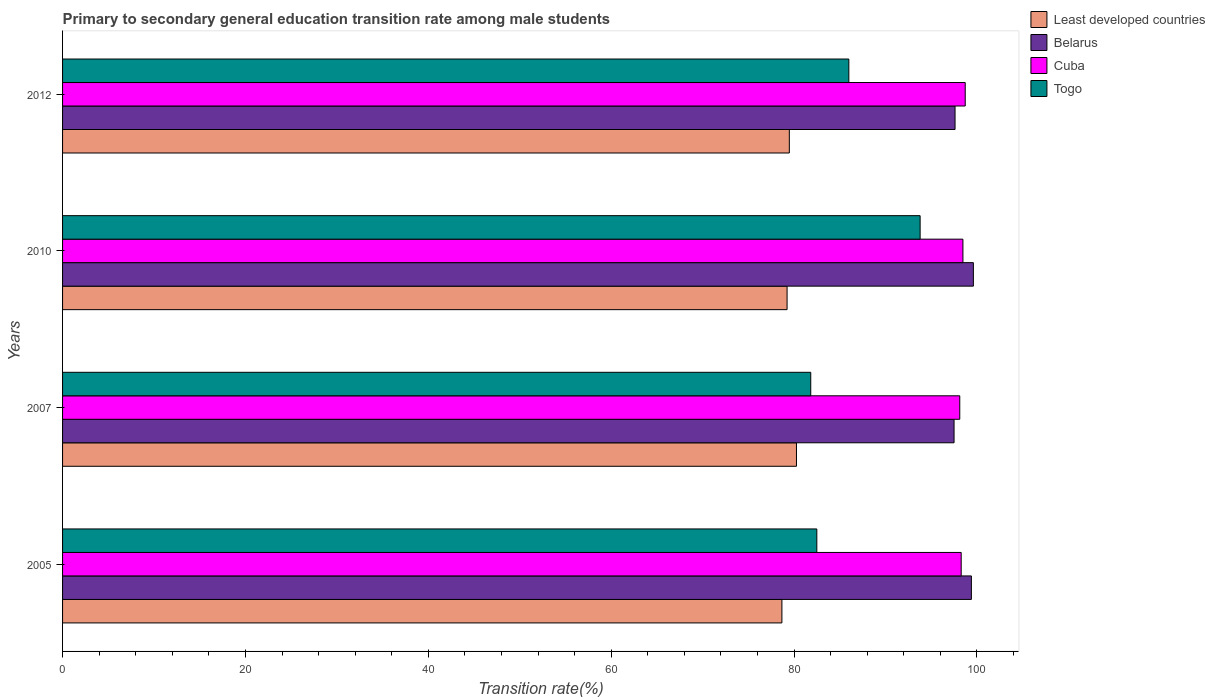Are the number of bars on each tick of the Y-axis equal?
Offer a terse response. Yes. What is the transition rate in Cuba in 2007?
Keep it short and to the point. 98.12. Across all years, what is the maximum transition rate in Cuba?
Keep it short and to the point. 98.72. Across all years, what is the minimum transition rate in Least developed countries?
Give a very brief answer. 78.67. In which year was the transition rate in Cuba minimum?
Your answer should be very brief. 2007. What is the total transition rate in Least developed countries in the graph?
Keep it short and to the point. 317.64. What is the difference between the transition rate in Belarus in 2005 and that in 2010?
Your answer should be compact. -0.22. What is the difference between the transition rate in Belarus in 2010 and the transition rate in Least developed countries in 2005?
Your response must be concise. 20.94. What is the average transition rate in Togo per year?
Keep it short and to the point. 86.02. In the year 2007, what is the difference between the transition rate in Cuba and transition rate in Least developed countries?
Offer a terse response. 17.86. In how many years, is the transition rate in Belarus greater than 12 %?
Offer a very short reply. 4. What is the ratio of the transition rate in Belarus in 2010 to that in 2012?
Keep it short and to the point. 1.02. Is the transition rate in Least developed countries in 2010 less than that in 2012?
Offer a terse response. Yes. Is the difference between the transition rate in Cuba in 2007 and 2012 greater than the difference between the transition rate in Least developed countries in 2007 and 2012?
Your answer should be very brief. No. What is the difference between the highest and the second highest transition rate in Togo?
Ensure brevity in your answer.  7.8. What is the difference between the highest and the lowest transition rate in Least developed countries?
Your response must be concise. 1.59. Is the sum of the transition rate in Togo in 2007 and 2010 greater than the maximum transition rate in Least developed countries across all years?
Make the answer very short. Yes. What does the 1st bar from the top in 2007 represents?
Provide a succinct answer. Togo. What does the 4th bar from the bottom in 2010 represents?
Offer a terse response. Togo. Is it the case that in every year, the sum of the transition rate in Cuba and transition rate in Belarus is greater than the transition rate in Togo?
Keep it short and to the point. Yes. How many years are there in the graph?
Keep it short and to the point. 4. Does the graph contain any zero values?
Offer a very short reply. No. Does the graph contain grids?
Provide a succinct answer. No. How are the legend labels stacked?
Provide a short and direct response. Vertical. What is the title of the graph?
Make the answer very short. Primary to secondary general education transition rate among male students. Does "Trinidad and Tobago" appear as one of the legend labels in the graph?
Ensure brevity in your answer.  No. What is the label or title of the X-axis?
Provide a short and direct response. Transition rate(%). What is the Transition rate(%) of Least developed countries in 2005?
Your answer should be very brief. 78.67. What is the Transition rate(%) of Belarus in 2005?
Ensure brevity in your answer.  99.39. What is the Transition rate(%) in Cuba in 2005?
Make the answer very short. 98.28. What is the Transition rate(%) of Togo in 2005?
Give a very brief answer. 82.49. What is the Transition rate(%) of Least developed countries in 2007?
Provide a short and direct response. 80.26. What is the Transition rate(%) in Belarus in 2007?
Offer a very short reply. 97.49. What is the Transition rate(%) of Cuba in 2007?
Make the answer very short. 98.12. What is the Transition rate(%) in Togo in 2007?
Make the answer very short. 81.82. What is the Transition rate(%) in Least developed countries in 2010?
Provide a succinct answer. 79.23. What is the Transition rate(%) of Belarus in 2010?
Offer a very short reply. 99.61. What is the Transition rate(%) of Cuba in 2010?
Ensure brevity in your answer.  98.46. What is the Transition rate(%) in Togo in 2010?
Keep it short and to the point. 93.78. What is the Transition rate(%) in Least developed countries in 2012?
Ensure brevity in your answer.  79.48. What is the Transition rate(%) in Belarus in 2012?
Your answer should be very brief. 97.6. What is the Transition rate(%) in Cuba in 2012?
Ensure brevity in your answer.  98.72. What is the Transition rate(%) of Togo in 2012?
Provide a short and direct response. 85.99. Across all years, what is the maximum Transition rate(%) in Least developed countries?
Give a very brief answer. 80.26. Across all years, what is the maximum Transition rate(%) in Belarus?
Keep it short and to the point. 99.61. Across all years, what is the maximum Transition rate(%) of Cuba?
Ensure brevity in your answer.  98.72. Across all years, what is the maximum Transition rate(%) in Togo?
Your answer should be very brief. 93.78. Across all years, what is the minimum Transition rate(%) of Least developed countries?
Keep it short and to the point. 78.67. Across all years, what is the minimum Transition rate(%) in Belarus?
Provide a succinct answer. 97.49. Across all years, what is the minimum Transition rate(%) of Cuba?
Keep it short and to the point. 98.12. Across all years, what is the minimum Transition rate(%) of Togo?
Ensure brevity in your answer.  81.82. What is the total Transition rate(%) in Least developed countries in the graph?
Provide a short and direct response. 317.64. What is the total Transition rate(%) in Belarus in the graph?
Your response must be concise. 394.1. What is the total Transition rate(%) of Cuba in the graph?
Keep it short and to the point. 393.58. What is the total Transition rate(%) in Togo in the graph?
Offer a terse response. 344.08. What is the difference between the Transition rate(%) in Least developed countries in 2005 and that in 2007?
Give a very brief answer. -1.59. What is the difference between the Transition rate(%) of Belarus in 2005 and that in 2007?
Offer a very short reply. 1.9. What is the difference between the Transition rate(%) of Cuba in 2005 and that in 2007?
Provide a succinct answer. 0.16. What is the difference between the Transition rate(%) of Togo in 2005 and that in 2007?
Provide a short and direct response. 0.66. What is the difference between the Transition rate(%) of Least developed countries in 2005 and that in 2010?
Offer a very short reply. -0.57. What is the difference between the Transition rate(%) in Belarus in 2005 and that in 2010?
Your response must be concise. -0.22. What is the difference between the Transition rate(%) in Cuba in 2005 and that in 2010?
Make the answer very short. -0.19. What is the difference between the Transition rate(%) of Togo in 2005 and that in 2010?
Your answer should be compact. -11.3. What is the difference between the Transition rate(%) of Least developed countries in 2005 and that in 2012?
Ensure brevity in your answer.  -0.81. What is the difference between the Transition rate(%) in Belarus in 2005 and that in 2012?
Your answer should be very brief. 1.79. What is the difference between the Transition rate(%) in Cuba in 2005 and that in 2012?
Your response must be concise. -0.44. What is the difference between the Transition rate(%) of Togo in 2005 and that in 2012?
Offer a very short reply. -3.5. What is the difference between the Transition rate(%) of Least developed countries in 2007 and that in 2010?
Offer a very short reply. 1.03. What is the difference between the Transition rate(%) in Belarus in 2007 and that in 2010?
Provide a succinct answer. -2.11. What is the difference between the Transition rate(%) of Cuba in 2007 and that in 2010?
Offer a very short reply. -0.34. What is the difference between the Transition rate(%) in Togo in 2007 and that in 2010?
Your response must be concise. -11.96. What is the difference between the Transition rate(%) of Least developed countries in 2007 and that in 2012?
Your response must be concise. 0.78. What is the difference between the Transition rate(%) in Belarus in 2007 and that in 2012?
Ensure brevity in your answer.  -0.11. What is the difference between the Transition rate(%) in Cuba in 2007 and that in 2012?
Ensure brevity in your answer.  -0.6. What is the difference between the Transition rate(%) of Togo in 2007 and that in 2012?
Your answer should be compact. -4.17. What is the difference between the Transition rate(%) of Least developed countries in 2010 and that in 2012?
Provide a succinct answer. -0.25. What is the difference between the Transition rate(%) of Belarus in 2010 and that in 2012?
Provide a succinct answer. 2. What is the difference between the Transition rate(%) of Cuba in 2010 and that in 2012?
Give a very brief answer. -0.25. What is the difference between the Transition rate(%) of Togo in 2010 and that in 2012?
Your answer should be compact. 7.8. What is the difference between the Transition rate(%) in Least developed countries in 2005 and the Transition rate(%) in Belarus in 2007?
Offer a very short reply. -18.83. What is the difference between the Transition rate(%) of Least developed countries in 2005 and the Transition rate(%) of Cuba in 2007?
Provide a succinct answer. -19.45. What is the difference between the Transition rate(%) in Least developed countries in 2005 and the Transition rate(%) in Togo in 2007?
Your response must be concise. -3.15. What is the difference between the Transition rate(%) of Belarus in 2005 and the Transition rate(%) of Cuba in 2007?
Provide a short and direct response. 1.27. What is the difference between the Transition rate(%) in Belarus in 2005 and the Transition rate(%) in Togo in 2007?
Offer a very short reply. 17.57. What is the difference between the Transition rate(%) of Cuba in 2005 and the Transition rate(%) of Togo in 2007?
Provide a succinct answer. 16.45. What is the difference between the Transition rate(%) of Least developed countries in 2005 and the Transition rate(%) of Belarus in 2010?
Make the answer very short. -20.94. What is the difference between the Transition rate(%) of Least developed countries in 2005 and the Transition rate(%) of Cuba in 2010?
Offer a terse response. -19.8. What is the difference between the Transition rate(%) in Least developed countries in 2005 and the Transition rate(%) in Togo in 2010?
Your answer should be very brief. -15.12. What is the difference between the Transition rate(%) in Belarus in 2005 and the Transition rate(%) in Cuba in 2010?
Your answer should be compact. 0.93. What is the difference between the Transition rate(%) in Belarus in 2005 and the Transition rate(%) in Togo in 2010?
Ensure brevity in your answer.  5.61. What is the difference between the Transition rate(%) of Cuba in 2005 and the Transition rate(%) of Togo in 2010?
Offer a terse response. 4.49. What is the difference between the Transition rate(%) in Least developed countries in 2005 and the Transition rate(%) in Belarus in 2012?
Provide a short and direct response. -18.94. What is the difference between the Transition rate(%) of Least developed countries in 2005 and the Transition rate(%) of Cuba in 2012?
Keep it short and to the point. -20.05. What is the difference between the Transition rate(%) of Least developed countries in 2005 and the Transition rate(%) of Togo in 2012?
Offer a terse response. -7.32. What is the difference between the Transition rate(%) of Belarus in 2005 and the Transition rate(%) of Cuba in 2012?
Provide a succinct answer. 0.67. What is the difference between the Transition rate(%) of Belarus in 2005 and the Transition rate(%) of Togo in 2012?
Your answer should be compact. 13.4. What is the difference between the Transition rate(%) of Cuba in 2005 and the Transition rate(%) of Togo in 2012?
Give a very brief answer. 12.29. What is the difference between the Transition rate(%) of Least developed countries in 2007 and the Transition rate(%) of Belarus in 2010?
Your response must be concise. -19.35. What is the difference between the Transition rate(%) of Least developed countries in 2007 and the Transition rate(%) of Cuba in 2010?
Make the answer very short. -18.2. What is the difference between the Transition rate(%) in Least developed countries in 2007 and the Transition rate(%) in Togo in 2010?
Offer a terse response. -13.52. What is the difference between the Transition rate(%) of Belarus in 2007 and the Transition rate(%) of Cuba in 2010?
Your answer should be very brief. -0.97. What is the difference between the Transition rate(%) of Belarus in 2007 and the Transition rate(%) of Togo in 2010?
Your answer should be compact. 3.71. What is the difference between the Transition rate(%) of Cuba in 2007 and the Transition rate(%) of Togo in 2010?
Your response must be concise. 4.33. What is the difference between the Transition rate(%) in Least developed countries in 2007 and the Transition rate(%) in Belarus in 2012?
Your response must be concise. -17.34. What is the difference between the Transition rate(%) of Least developed countries in 2007 and the Transition rate(%) of Cuba in 2012?
Provide a succinct answer. -18.45. What is the difference between the Transition rate(%) in Least developed countries in 2007 and the Transition rate(%) in Togo in 2012?
Your response must be concise. -5.73. What is the difference between the Transition rate(%) in Belarus in 2007 and the Transition rate(%) in Cuba in 2012?
Offer a very short reply. -1.22. What is the difference between the Transition rate(%) in Belarus in 2007 and the Transition rate(%) in Togo in 2012?
Provide a short and direct response. 11.51. What is the difference between the Transition rate(%) in Cuba in 2007 and the Transition rate(%) in Togo in 2012?
Your answer should be compact. 12.13. What is the difference between the Transition rate(%) in Least developed countries in 2010 and the Transition rate(%) in Belarus in 2012?
Your answer should be compact. -18.37. What is the difference between the Transition rate(%) in Least developed countries in 2010 and the Transition rate(%) in Cuba in 2012?
Your answer should be compact. -19.48. What is the difference between the Transition rate(%) in Least developed countries in 2010 and the Transition rate(%) in Togo in 2012?
Keep it short and to the point. -6.76. What is the difference between the Transition rate(%) of Belarus in 2010 and the Transition rate(%) of Cuba in 2012?
Offer a terse response. 0.89. What is the difference between the Transition rate(%) in Belarus in 2010 and the Transition rate(%) in Togo in 2012?
Offer a terse response. 13.62. What is the difference between the Transition rate(%) in Cuba in 2010 and the Transition rate(%) in Togo in 2012?
Your response must be concise. 12.47. What is the average Transition rate(%) of Least developed countries per year?
Keep it short and to the point. 79.41. What is the average Transition rate(%) of Belarus per year?
Make the answer very short. 98.52. What is the average Transition rate(%) of Cuba per year?
Offer a very short reply. 98.39. What is the average Transition rate(%) in Togo per year?
Make the answer very short. 86.02. In the year 2005, what is the difference between the Transition rate(%) of Least developed countries and Transition rate(%) of Belarus?
Offer a very short reply. -20.72. In the year 2005, what is the difference between the Transition rate(%) in Least developed countries and Transition rate(%) in Cuba?
Offer a very short reply. -19.61. In the year 2005, what is the difference between the Transition rate(%) in Least developed countries and Transition rate(%) in Togo?
Your answer should be very brief. -3.82. In the year 2005, what is the difference between the Transition rate(%) in Belarus and Transition rate(%) in Cuba?
Make the answer very short. 1.11. In the year 2005, what is the difference between the Transition rate(%) of Belarus and Transition rate(%) of Togo?
Your answer should be compact. 16.9. In the year 2005, what is the difference between the Transition rate(%) in Cuba and Transition rate(%) in Togo?
Ensure brevity in your answer.  15.79. In the year 2007, what is the difference between the Transition rate(%) of Least developed countries and Transition rate(%) of Belarus?
Provide a short and direct response. -17.23. In the year 2007, what is the difference between the Transition rate(%) of Least developed countries and Transition rate(%) of Cuba?
Provide a short and direct response. -17.86. In the year 2007, what is the difference between the Transition rate(%) in Least developed countries and Transition rate(%) in Togo?
Your response must be concise. -1.56. In the year 2007, what is the difference between the Transition rate(%) of Belarus and Transition rate(%) of Cuba?
Your answer should be very brief. -0.62. In the year 2007, what is the difference between the Transition rate(%) of Belarus and Transition rate(%) of Togo?
Give a very brief answer. 15.67. In the year 2007, what is the difference between the Transition rate(%) of Cuba and Transition rate(%) of Togo?
Make the answer very short. 16.3. In the year 2010, what is the difference between the Transition rate(%) in Least developed countries and Transition rate(%) in Belarus?
Offer a very short reply. -20.37. In the year 2010, what is the difference between the Transition rate(%) in Least developed countries and Transition rate(%) in Cuba?
Ensure brevity in your answer.  -19.23. In the year 2010, what is the difference between the Transition rate(%) in Least developed countries and Transition rate(%) in Togo?
Provide a short and direct response. -14.55. In the year 2010, what is the difference between the Transition rate(%) in Belarus and Transition rate(%) in Cuba?
Offer a terse response. 1.14. In the year 2010, what is the difference between the Transition rate(%) of Belarus and Transition rate(%) of Togo?
Provide a short and direct response. 5.82. In the year 2010, what is the difference between the Transition rate(%) in Cuba and Transition rate(%) in Togo?
Your response must be concise. 4.68. In the year 2012, what is the difference between the Transition rate(%) in Least developed countries and Transition rate(%) in Belarus?
Make the answer very short. -18.12. In the year 2012, what is the difference between the Transition rate(%) in Least developed countries and Transition rate(%) in Cuba?
Offer a very short reply. -19.24. In the year 2012, what is the difference between the Transition rate(%) of Least developed countries and Transition rate(%) of Togo?
Provide a succinct answer. -6.51. In the year 2012, what is the difference between the Transition rate(%) in Belarus and Transition rate(%) in Cuba?
Your answer should be compact. -1.11. In the year 2012, what is the difference between the Transition rate(%) in Belarus and Transition rate(%) in Togo?
Your answer should be compact. 11.61. In the year 2012, what is the difference between the Transition rate(%) in Cuba and Transition rate(%) in Togo?
Give a very brief answer. 12.73. What is the ratio of the Transition rate(%) in Least developed countries in 2005 to that in 2007?
Your answer should be very brief. 0.98. What is the ratio of the Transition rate(%) of Belarus in 2005 to that in 2007?
Provide a succinct answer. 1.02. What is the ratio of the Transition rate(%) in Cuba in 2005 to that in 2007?
Keep it short and to the point. 1. What is the ratio of the Transition rate(%) of Togo in 2005 to that in 2007?
Your answer should be compact. 1.01. What is the ratio of the Transition rate(%) in Cuba in 2005 to that in 2010?
Make the answer very short. 1. What is the ratio of the Transition rate(%) of Togo in 2005 to that in 2010?
Your response must be concise. 0.88. What is the ratio of the Transition rate(%) in Least developed countries in 2005 to that in 2012?
Keep it short and to the point. 0.99. What is the ratio of the Transition rate(%) of Belarus in 2005 to that in 2012?
Ensure brevity in your answer.  1.02. What is the ratio of the Transition rate(%) of Togo in 2005 to that in 2012?
Ensure brevity in your answer.  0.96. What is the ratio of the Transition rate(%) of Belarus in 2007 to that in 2010?
Make the answer very short. 0.98. What is the ratio of the Transition rate(%) in Cuba in 2007 to that in 2010?
Your response must be concise. 1. What is the ratio of the Transition rate(%) in Togo in 2007 to that in 2010?
Keep it short and to the point. 0.87. What is the ratio of the Transition rate(%) of Least developed countries in 2007 to that in 2012?
Give a very brief answer. 1.01. What is the ratio of the Transition rate(%) of Belarus in 2007 to that in 2012?
Your answer should be very brief. 1. What is the ratio of the Transition rate(%) in Cuba in 2007 to that in 2012?
Ensure brevity in your answer.  0.99. What is the ratio of the Transition rate(%) of Togo in 2007 to that in 2012?
Give a very brief answer. 0.95. What is the ratio of the Transition rate(%) in Belarus in 2010 to that in 2012?
Ensure brevity in your answer.  1.02. What is the ratio of the Transition rate(%) of Cuba in 2010 to that in 2012?
Offer a terse response. 1. What is the ratio of the Transition rate(%) in Togo in 2010 to that in 2012?
Your response must be concise. 1.09. What is the difference between the highest and the second highest Transition rate(%) of Least developed countries?
Make the answer very short. 0.78. What is the difference between the highest and the second highest Transition rate(%) of Belarus?
Offer a terse response. 0.22. What is the difference between the highest and the second highest Transition rate(%) of Cuba?
Your response must be concise. 0.25. What is the difference between the highest and the second highest Transition rate(%) in Togo?
Make the answer very short. 7.8. What is the difference between the highest and the lowest Transition rate(%) in Least developed countries?
Make the answer very short. 1.59. What is the difference between the highest and the lowest Transition rate(%) of Belarus?
Provide a short and direct response. 2.11. What is the difference between the highest and the lowest Transition rate(%) in Cuba?
Your response must be concise. 0.6. What is the difference between the highest and the lowest Transition rate(%) in Togo?
Provide a succinct answer. 11.96. 